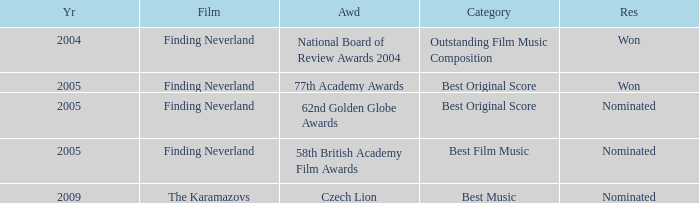What were the outcomes for the years before 2005? Won. 